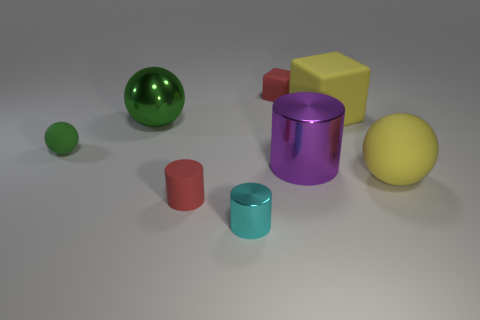There is a red object that is in front of the big ball that is to the right of the tiny cube; what size is it?
Ensure brevity in your answer.  Small. How many cubes are large gray metallic objects or large purple things?
Provide a succinct answer. 0. The matte cube that is the same size as the purple shiny thing is what color?
Provide a short and direct response. Yellow. What is the shape of the red rubber object behind the big matte cube that is behind the big purple cylinder?
Make the answer very short. Cube. Do the cylinder that is behind the red rubber cylinder and the red cylinder have the same size?
Offer a terse response. No. What number of other things are there of the same material as the small green object
Your response must be concise. 4. What number of green things are either tiny things or rubber things?
Provide a short and direct response. 1. There is a metal sphere that is the same color as the small rubber sphere; what size is it?
Your answer should be very brief. Large. There is a green rubber ball; what number of small blocks are in front of it?
Your answer should be very brief. 0. There is a rubber sphere on the right side of the red rubber thing that is behind the large purple shiny thing that is behind the small matte cylinder; what size is it?
Make the answer very short. Large. 